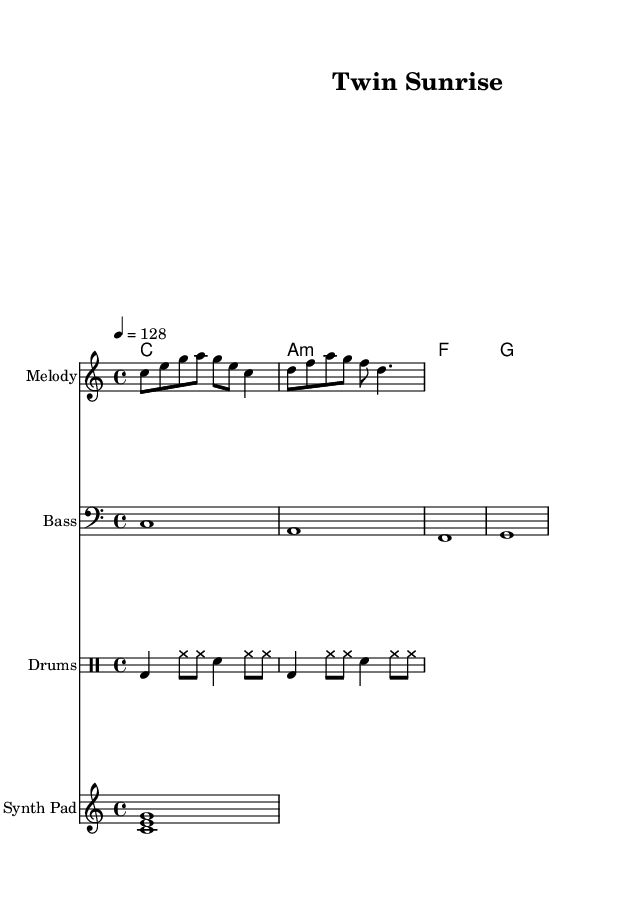What is the key signature of this music? The key signature is C major, which has no sharps or flats.
Answer: C major What is the time signature of this piece? The time signature is indicated as four beats per measure, showing how the music is structured rhythmically.
Answer: 4/4 What tempo is indicated in the score? The tempo marking in the score indicates that the piece should be played at a speed of 128 beats per minute, guiding the performance pace.
Answer: 128 How many measures are in the melody? By counting the written notes and their groupings, there are 2 measures, as indicated in the rhythm layout of the melody line.
Answer: 2 What type of drum is used in the drum part? The drum part includes a bass drum and snare drum, which are common instruments used in electronic musical compositions for a strong rhythm.
Answer: Bass and snare What is the function of the synth pad in this composition? The synth pad typically provides atmospheric sound and harmony, enriching the texture of the music and supporting the melody.
Answer: Harmony and atmosphere Which chord is the first chord in the harmony? By examining the chord symbols at the beginning, the first chord played is a C major chord, which establishes the tonal center for the piece.
Answer: C 